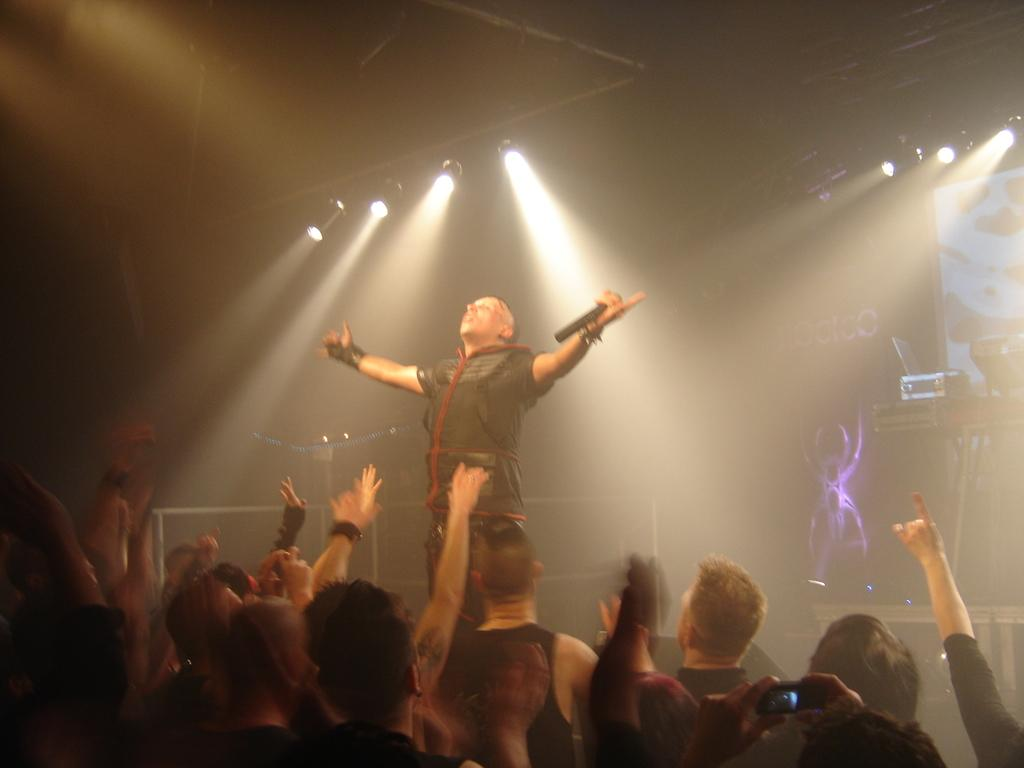What is the man in the image holding? The man is holding a microphone in the image. Who else is present in the image besides the man with the microphone? There is a group of people in the image. What can be seen in the image that might be used for illumination? There are lights visible in the image. What might be used for displaying information or visuals in the image? There is a screen in the image. What type of furniture is present in the image? There is a table in the image. Can you describe the unspecified object in the image? The unspecified object is not described in the provided facts, so it cannot be identified. Can you describe the behavior of the whip in the image? There is no whip present in the image, so its behavior cannot be described. 